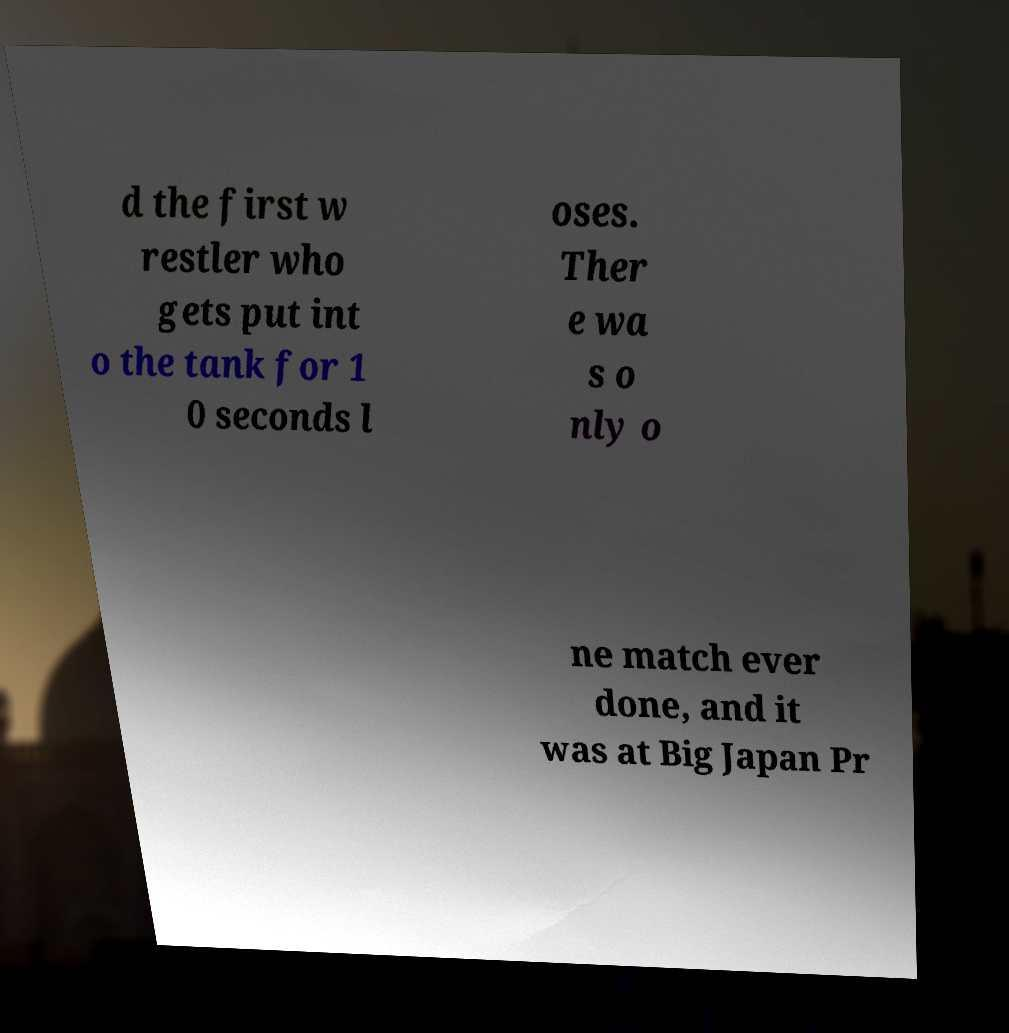There's text embedded in this image that I need extracted. Can you transcribe it verbatim? d the first w restler who gets put int o the tank for 1 0 seconds l oses. Ther e wa s o nly o ne match ever done, and it was at Big Japan Pr 